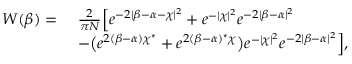Convert formula to latex. <formula><loc_0><loc_0><loc_500><loc_500>\begin{array} { r l } { W ( \beta ) = \ } & { \frac { 2 } { \pi N } \left [ e ^ { - 2 | \beta - \alpha - \chi | ^ { 2 } } + e ^ { - | \chi | ^ { 2 } } e ^ { - 2 | \beta - \alpha | ^ { 2 } } } \\ & { - \left ( e ^ { 2 ( \beta - \alpha ) \chi ^ { * } } + e ^ { 2 ( \beta - \alpha ) ^ { * } \chi } \right ) e ^ { - | \chi | ^ { 2 } } e ^ { - 2 | \beta - \alpha | ^ { 2 } } \right ] , } \end{array}</formula> 